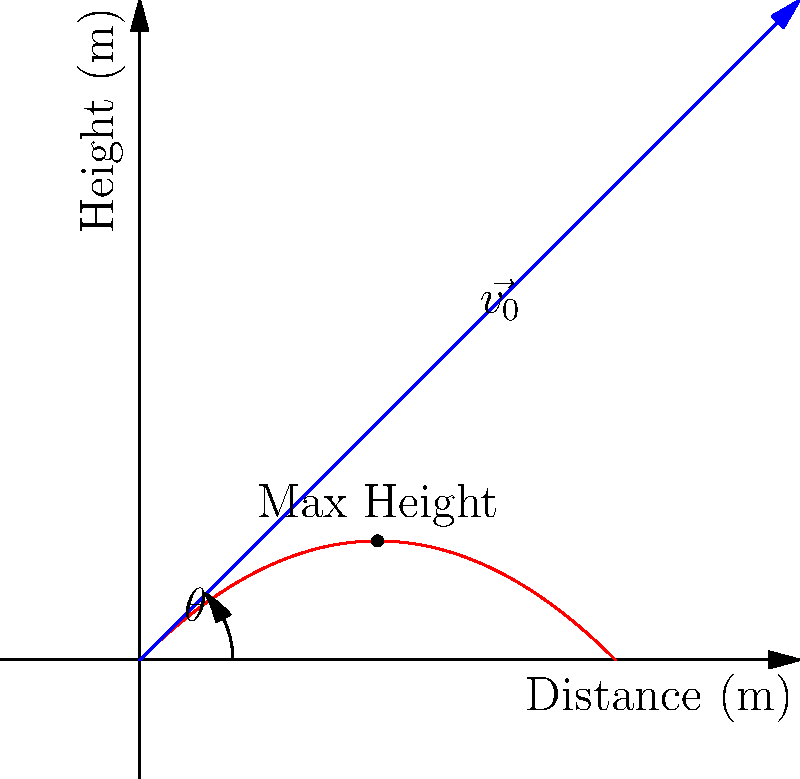In a political satire skit, a comedian throws a pie with an initial velocity of 5 m/s at an angle of 45° above the horizontal. Assuming no air resistance, what is the maximum height reached by the pie before it begins to descend? To find the maximum height of the pie's trajectory, we'll follow these steps:

1. Identify the relevant equations:
   - Vertical motion: $y = v_0 \sin(\theta) \cdot t - \frac{1}{2}gt^2$
   - Time to reach maximum height: $t_{max} = \frac{v_0 \sin(\theta)}{g}$

2. Given information:
   - Initial velocity, $v_0 = 5$ m/s
   - Angle, $\theta = 45°$
   - Gravitational acceleration, $g = 9.8$ m/s²

3. Calculate the vertical component of initial velocity:
   $v_{0y} = v_0 \sin(\theta) = 5 \sin(45°) = 5 \cdot \frac{\sqrt{2}}{2} \approx 3.54$ m/s

4. Calculate the time to reach maximum height:
   $t_{max} = \frac{v_{0y}}{g} = \frac{3.54}{9.8} \approx 0.36$ s

5. Calculate the maximum height using the vertical motion equation:
   $y_{max} = v_{0y} \cdot t_{max} - \frac{1}{2}g \cdot t_{max}^2$
   $y_{max} = 3.54 \cdot 0.36 - \frac{1}{2} \cdot 9.8 \cdot 0.36^2$
   $y_{max} = 1.27 - 0.64 = 0.63$ m

Therefore, the maximum height reached by the pie is approximately 0.63 meters.
Answer: 0.63 m 